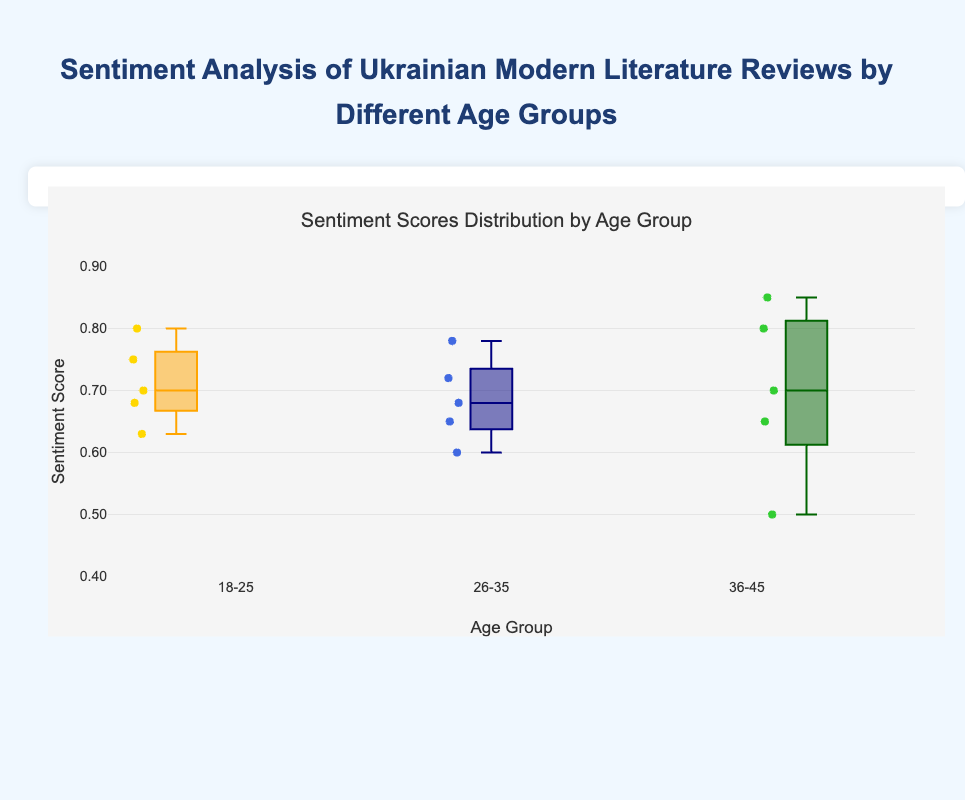What is the title of the figure? The title of the figure is displayed at the top center.
Answer: Sentiment Analysis of Ukrainian Modern Literature Reviews by Different Age Groups Which age group has the highest median sentiment score? By checking the middle line inside each box, the 36-45 age group has the median value at a higher position than the others.
Answer: 36-45 What is the sentiment score range for the age group 18-25? The range spans from the bottom to the top of the box plot, with additional whiskers representing the minimum and maximum values.
Answer: 0.63 to 0.80 Which age group shows the widest range of sentiment scores? The widest range is indicated by the longest box and whiskers combined.
Answer: 36-45 How does the median sentiment score for the age group 26-35 compare with the age group 18-25? Comparing the middle lines of both boxes, the age group 26-35 has a slightly lower median than 18-25.
Answer: Lower Which book has the highest sentiment score in the 36-45 age group? The highest individual data point within the 36-45 age group box plot indicates the book with the highest sentiment score.
Answer: The Death and the Penguin by Andrey Kurkov Is there any overlap between the sentiment score ranges of different age groups? Observing the whiskers and the boxes, overlaps in the range of sentiment scores can be identified.
Answer: Yes Which age group has the smallest interquartile range (IQR)? The height of each box (quartiles Q1 to Q3) indicates the IQR, and the smallest box represents the smallest IQR.
Answer: 26-35 What is the approximate sentiment score for the book "Felix Austria by Sofia Andrukhovych" in the age group 26-35? The scattered points inside the box plot for each age group can be used to find the sentiment score.
Answer: 0.60 